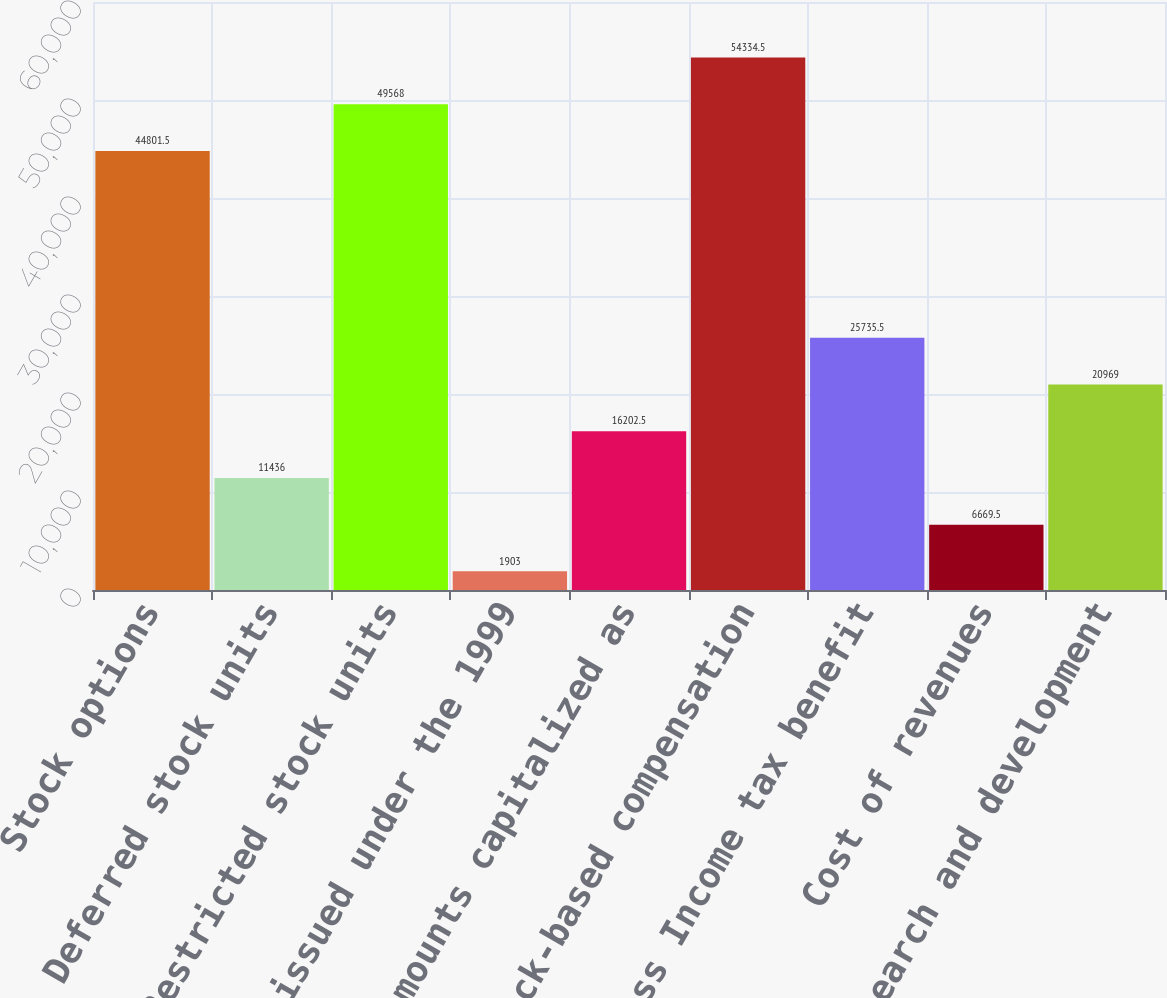Convert chart to OTSL. <chart><loc_0><loc_0><loc_500><loc_500><bar_chart><fcel>Stock options<fcel>Deferred stock units<fcel>Restricted stock units<fcel>Shares issued under the 1999<fcel>Amounts capitalized as<fcel>Total stock-based compensation<fcel>Less Income tax benefit<fcel>Cost of revenues<fcel>Research and development<nl><fcel>44801.5<fcel>11436<fcel>49568<fcel>1903<fcel>16202.5<fcel>54334.5<fcel>25735.5<fcel>6669.5<fcel>20969<nl></chart> 